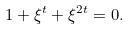<formula> <loc_0><loc_0><loc_500><loc_500>1 + \xi ^ { t } + \xi ^ { 2 t } = 0 .</formula> 